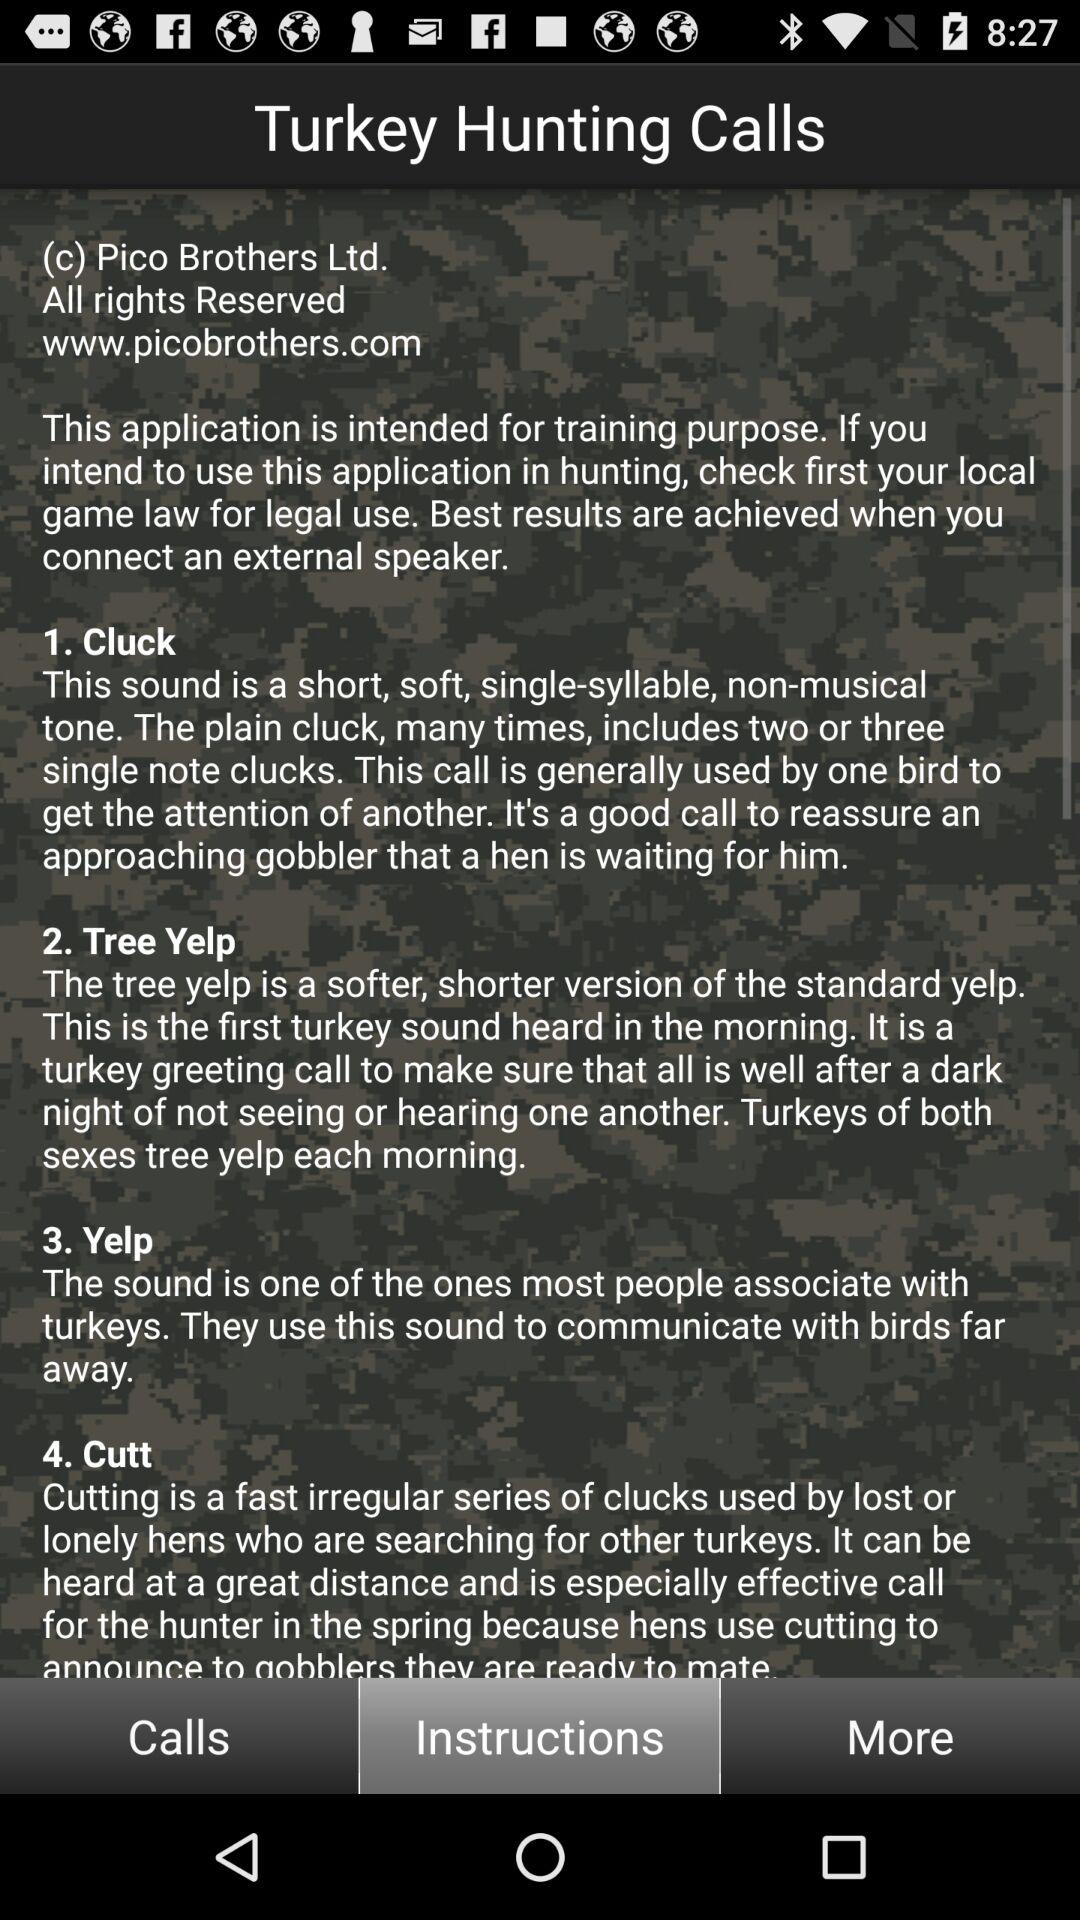Can the turkey hunting calls be heard?
When the provided information is insufficient, respond with <no answer>. <no answer> 